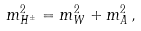<formula> <loc_0><loc_0><loc_500><loc_500>m _ { H ^ { \pm } } ^ { 2 } = m _ { W } ^ { 2 } + m _ { A } ^ { 2 } \, ,</formula> 